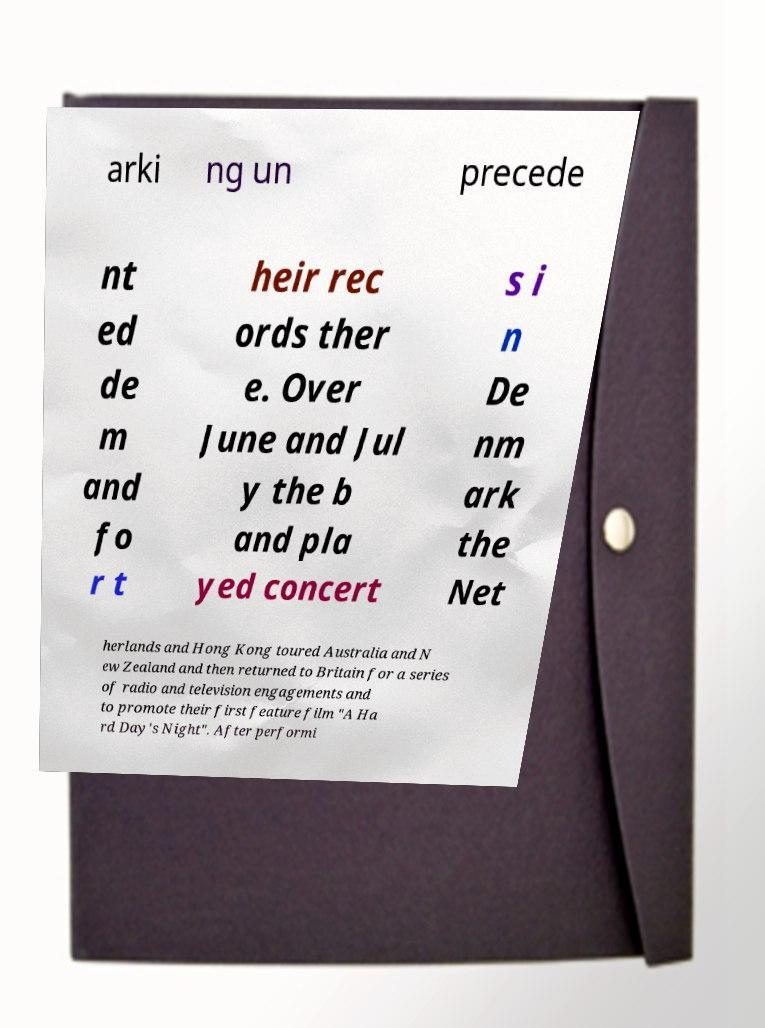I need the written content from this picture converted into text. Can you do that? arki ng un precede nt ed de m and fo r t heir rec ords ther e. Over June and Jul y the b and pla yed concert s i n De nm ark the Net herlands and Hong Kong toured Australia and N ew Zealand and then returned to Britain for a series of radio and television engagements and to promote their first feature film "A Ha rd Day's Night". After performi 